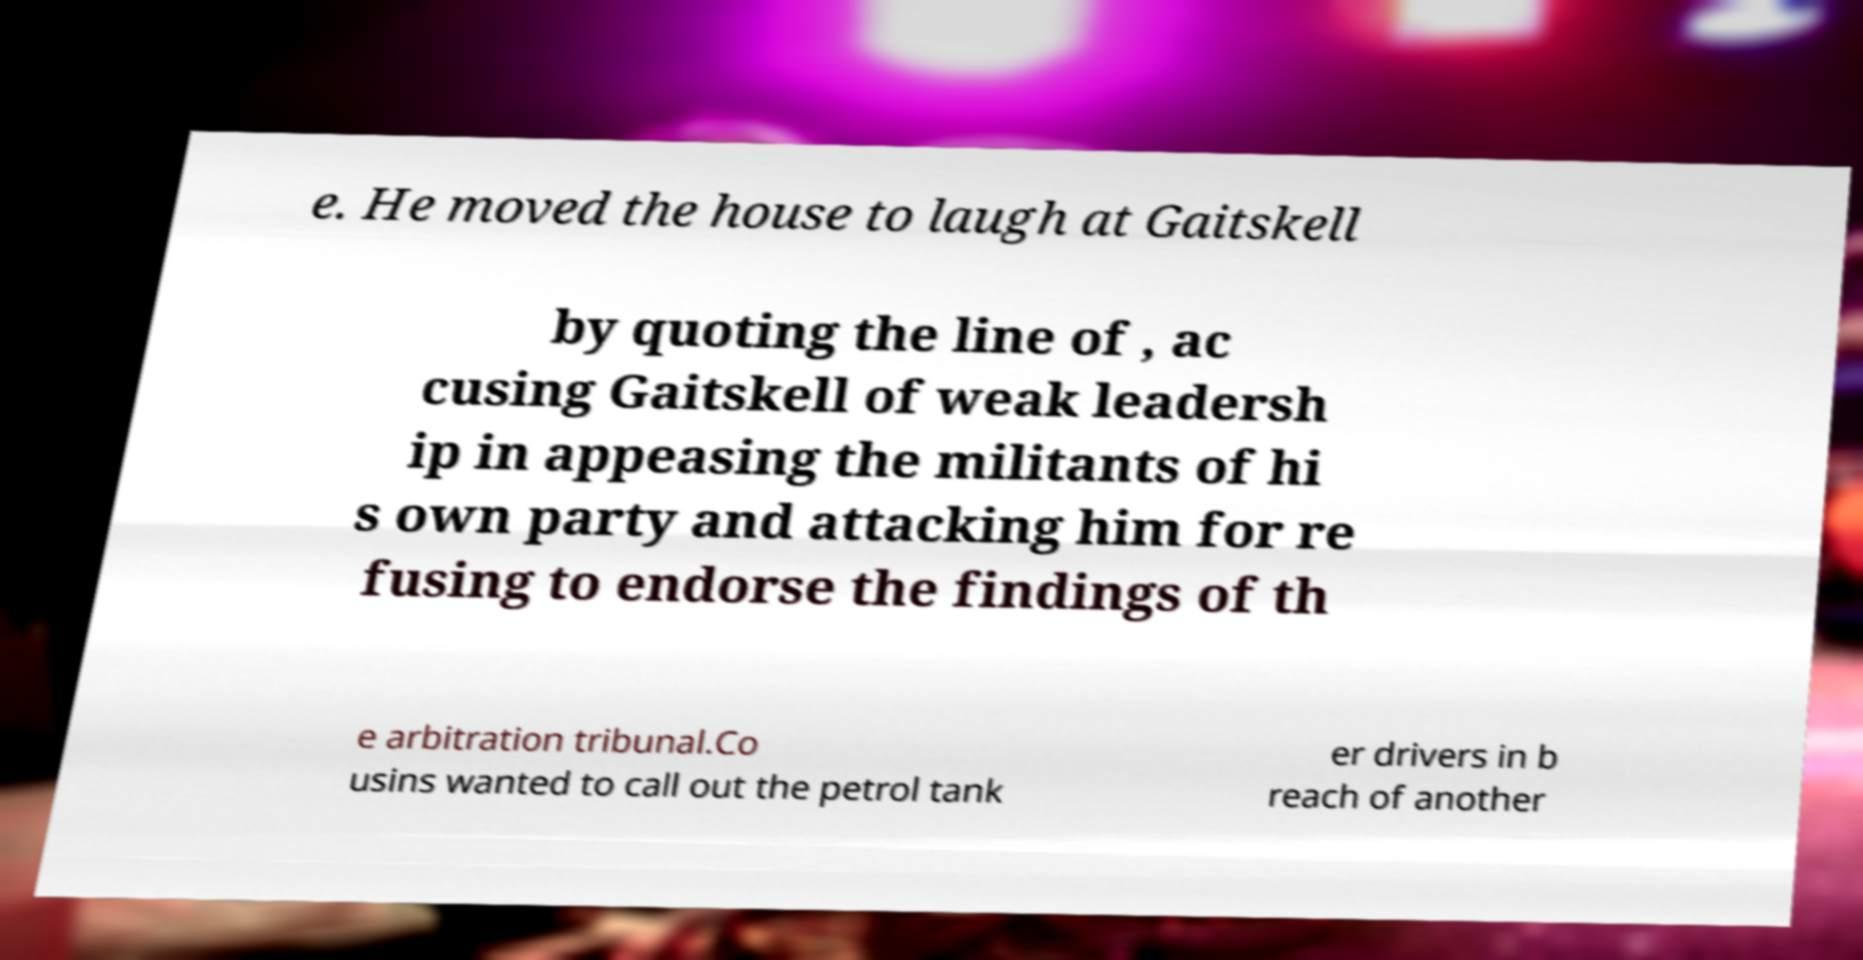Can you accurately transcribe the text from the provided image for me? e. He moved the house to laugh at Gaitskell by quoting the line of , ac cusing Gaitskell of weak leadersh ip in appeasing the militants of hi s own party and attacking him for re fusing to endorse the findings of th e arbitration tribunal.Co usins wanted to call out the petrol tank er drivers in b reach of another 